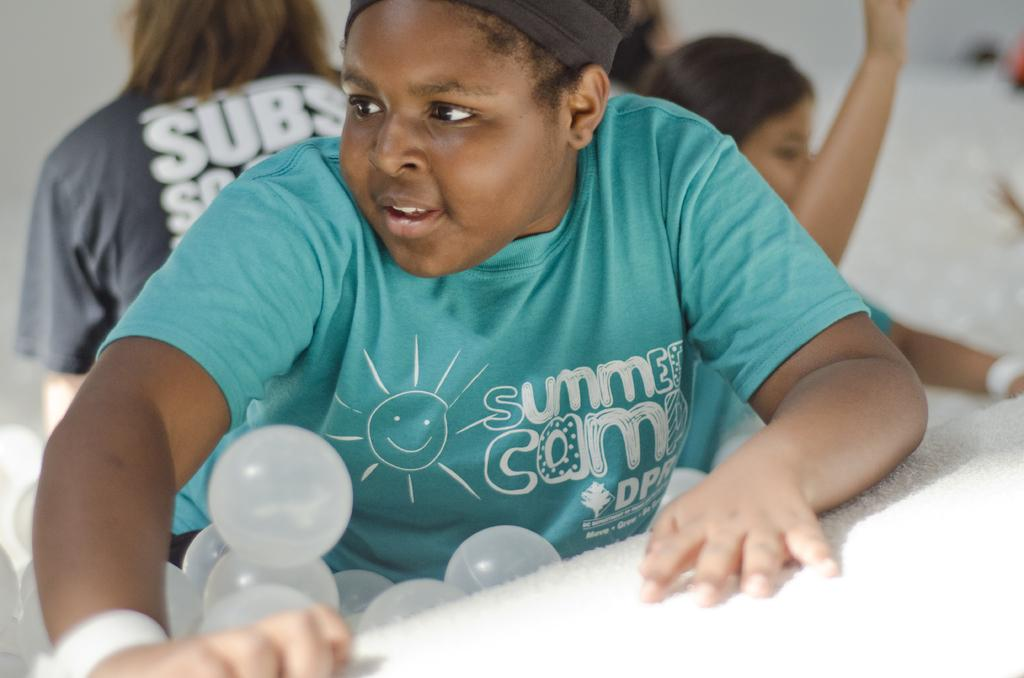Who is the main subject in the image? There is a boy in the image. What is the boy doing in the image? The boy is sitting in a chair. What is the boy holding or interacting with in the image? The boy has many balloons in his lap. Are there any other people visible in the image? Yes, there are other people visible behind the boy. What type of cup is the boy balancing on his head in the image? There is no cup visible in the image, nor is the boy balancing anything on his head. 